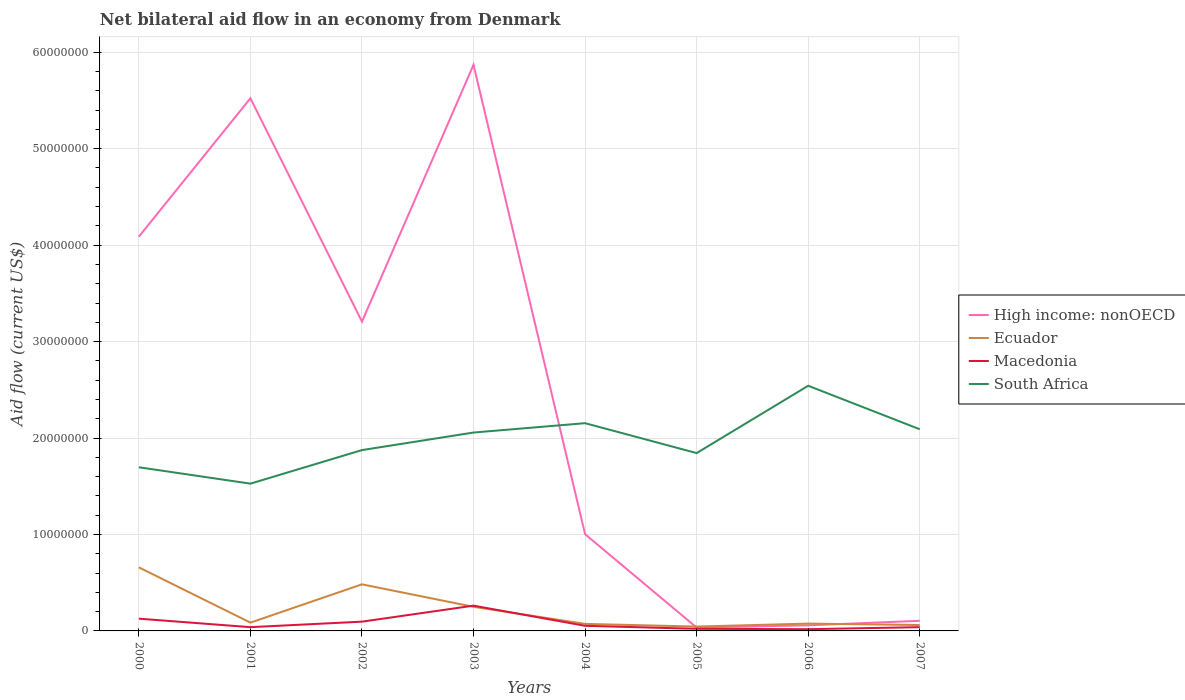How many different coloured lines are there?
Make the answer very short. 4. What is the total net bilateral aid flow in High income: nonOECD in the graph?
Your answer should be compact. -2.66e+07. What is the difference between the highest and the second highest net bilateral aid flow in High income: nonOECD?
Make the answer very short. 5.84e+07. What is the difference between the highest and the lowest net bilateral aid flow in High income: nonOECD?
Make the answer very short. 4. Is the net bilateral aid flow in Ecuador strictly greater than the net bilateral aid flow in Macedonia over the years?
Keep it short and to the point. No. Are the values on the major ticks of Y-axis written in scientific E-notation?
Offer a terse response. No. Does the graph contain grids?
Give a very brief answer. Yes. Where does the legend appear in the graph?
Offer a very short reply. Center right. What is the title of the graph?
Ensure brevity in your answer.  Net bilateral aid flow in an economy from Denmark. What is the label or title of the X-axis?
Provide a short and direct response. Years. What is the label or title of the Y-axis?
Keep it short and to the point. Aid flow (current US$). What is the Aid flow (current US$) of High income: nonOECD in 2000?
Make the answer very short. 4.09e+07. What is the Aid flow (current US$) in Ecuador in 2000?
Keep it short and to the point. 6.59e+06. What is the Aid flow (current US$) of Macedonia in 2000?
Offer a very short reply. 1.27e+06. What is the Aid flow (current US$) in South Africa in 2000?
Your answer should be very brief. 1.70e+07. What is the Aid flow (current US$) in High income: nonOECD in 2001?
Offer a terse response. 5.52e+07. What is the Aid flow (current US$) in Ecuador in 2001?
Offer a very short reply. 8.60e+05. What is the Aid flow (current US$) of South Africa in 2001?
Keep it short and to the point. 1.53e+07. What is the Aid flow (current US$) of High income: nonOECD in 2002?
Offer a terse response. 3.21e+07. What is the Aid flow (current US$) of Ecuador in 2002?
Your answer should be very brief. 4.83e+06. What is the Aid flow (current US$) in Macedonia in 2002?
Provide a short and direct response. 9.60e+05. What is the Aid flow (current US$) of South Africa in 2002?
Offer a very short reply. 1.88e+07. What is the Aid flow (current US$) in High income: nonOECD in 2003?
Offer a very short reply. 5.87e+07. What is the Aid flow (current US$) in Ecuador in 2003?
Offer a very short reply. 2.50e+06. What is the Aid flow (current US$) of Macedonia in 2003?
Offer a terse response. 2.62e+06. What is the Aid flow (current US$) in South Africa in 2003?
Ensure brevity in your answer.  2.06e+07. What is the Aid flow (current US$) in High income: nonOECD in 2004?
Ensure brevity in your answer.  1.00e+07. What is the Aid flow (current US$) in Ecuador in 2004?
Give a very brief answer. 7.30e+05. What is the Aid flow (current US$) in Macedonia in 2004?
Your answer should be compact. 5.30e+05. What is the Aid flow (current US$) in South Africa in 2004?
Offer a very short reply. 2.15e+07. What is the Aid flow (current US$) of High income: nonOECD in 2005?
Your answer should be very brief. 3.50e+05. What is the Aid flow (current US$) in Ecuador in 2005?
Your answer should be very brief. 4.50e+05. What is the Aid flow (current US$) in Macedonia in 2005?
Offer a very short reply. 2.20e+05. What is the Aid flow (current US$) in South Africa in 2005?
Your response must be concise. 1.84e+07. What is the Aid flow (current US$) of High income: nonOECD in 2006?
Make the answer very short. 5.80e+05. What is the Aid flow (current US$) of Ecuador in 2006?
Your answer should be compact. 7.60e+05. What is the Aid flow (current US$) of Macedonia in 2006?
Provide a short and direct response. 1.80e+05. What is the Aid flow (current US$) in South Africa in 2006?
Offer a terse response. 2.54e+07. What is the Aid flow (current US$) in High income: nonOECD in 2007?
Offer a very short reply. 1.05e+06. What is the Aid flow (current US$) of Ecuador in 2007?
Provide a short and direct response. 6.10e+05. What is the Aid flow (current US$) of Macedonia in 2007?
Keep it short and to the point. 3.90e+05. What is the Aid flow (current US$) in South Africa in 2007?
Ensure brevity in your answer.  2.09e+07. Across all years, what is the maximum Aid flow (current US$) of High income: nonOECD?
Your answer should be compact. 5.87e+07. Across all years, what is the maximum Aid flow (current US$) in Ecuador?
Offer a very short reply. 6.59e+06. Across all years, what is the maximum Aid flow (current US$) of Macedonia?
Your response must be concise. 2.62e+06. Across all years, what is the maximum Aid flow (current US$) in South Africa?
Your answer should be very brief. 2.54e+07. Across all years, what is the minimum Aid flow (current US$) of High income: nonOECD?
Make the answer very short. 3.50e+05. Across all years, what is the minimum Aid flow (current US$) in South Africa?
Offer a very short reply. 1.53e+07. What is the total Aid flow (current US$) of High income: nonOECD in the graph?
Ensure brevity in your answer.  1.99e+08. What is the total Aid flow (current US$) in Ecuador in the graph?
Keep it short and to the point. 1.73e+07. What is the total Aid flow (current US$) of Macedonia in the graph?
Provide a succinct answer. 6.56e+06. What is the total Aid flow (current US$) of South Africa in the graph?
Your answer should be very brief. 1.58e+08. What is the difference between the Aid flow (current US$) in High income: nonOECD in 2000 and that in 2001?
Give a very brief answer. -1.44e+07. What is the difference between the Aid flow (current US$) of Ecuador in 2000 and that in 2001?
Keep it short and to the point. 5.73e+06. What is the difference between the Aid flow (current US$) of Macedonia in 2000 and that in 2001?
Make the answer very short. 8.80e+05. What is the difference between the Aid flow (current US$) of South Africa in 2000 and that in 2001?
Make the answer very short. 1.70e+06. What is the difference between the Aid flow (current US$) in High income: nonOECD in 2000 and that in 2002?
Your answer should be very brief. 8.81e+06. What is the difference between the Aid flow (current US$) in Ecuador in 2000 and that in 2002?
Give a very brief answer. 1.76e+06. What is the difference between the Aid flow (current US$) in Macedonia in 2000 and that in 2002?
Your answer should be very brief. 3.10e+05. What is the difference between the Aid flow (current US$) in South Africa in 2000 and that in 2002?
Provide a short and direct response. -1.78e+06. What is the difference between the Aid flow (current US$) of High income: nonOECD in 2000 and that in 2003?
Your answer should be compact. -1.78e+07. What is the difference between the Aid flow (current US$) in Ecuador in 2000 and that in 2003?
Provide a short and direct response. 4.09e+06. What is the difference between the Aid flow (current US$) in Macedonia in 2000 and that in 2003?
Provide a short and direct response. -1.35e+06. What is the difference between the Aid flow (current US$) of South Africa in 2000 and that in 2003?
Provide a succinct answer. -3.60e+06. What is the difference between the Aid flow (current US$) of High income: nonOECD in 2000 and that in 2004?
Keep it short and to the point. 3.08e+07. What is the difference between the Aid flow (current US$) in Ecuador in 2000 and that in 2004?
Your response must be concise. 5.86e+06. What is the difference between the Aid flow (current US$) in Macedonia in 2000 and that in 2004?
Make the answer very short. 7.40e+05. What is the difference between the Aid flow (current US$) of South Africa in 2000 and that in 2004?
Offer a very short reply. -4.57e+06. What is the difference between the Aid flow (current US$) of High income: nonOECD in 2000 and that in 2005?
Offer a very short reply. 4.05e+07. What is the difference between the Aid flow (current US$) in Ecuador in 2000 and that in 2005?
Ensure brevity in your answer.  6.14e+06. What is the difference between the Aid flow (current US$) of Macedonia in 2000 and that in 2005?
Your answer should be very brief. 1.05e+06. What is the difference between the Aid flow (current US$) in South Africa in 2000 and that in 2005?
Offer a terse response. -1.47e+06. What is the difference between the Aid flow (current US$) of High income: nonOECD in 2000 and that in 2006?
Your answer should be very brief. 4.03e+07. What is the difference between the Aid flow (current US$) of Ecuador in 2000 and that in 2006?
Make the answer very short. 5.83e+06. What is the difference between the Aid flow (current US$) in Macedonia in 2000 and that in 2006?
Give a very brief answer. 1.09e+06. What is the difference between the Aid flow (current US$) in South Africa in 2000 and that in 2006?
Provide a short and direct response. -8.45e+06. What is the difference between the Aid flow (current US$) in High income: nonOECD in 2000 and that in 2007?
Your response must be concise. 3.98e+07. What is the difference between the Aid flow (current US$) of Ecuador in 2000 and that in 2007?
Make the answer very short. 5.98e+06. What is the difference between the Aid flow (current US$) in Macedonia in 2000 and that in 2007?
Offer a very short reply. 8.80e+05. What is the difference between the Aid flow (current US$) of South Africa in 2000 and that in 2007?
Your response must be concise. -3.94e+06. What is the difference between the Aid flow (current US$) of High income: nonOECD in 2001 and that in 2002?
Offer a terse response. 2.32e+07. What is the difference between the Aid flow (current US$) in Ecuador in 2001 and that in 2002?
Make the answer very short. -3.97e+06. What is the difference between the Aid flow (current US$) in Macedonia in 2001 and that in 2002?
Your answer should be compact. -5.70e+05. What is the difference between the Aid flow (current US$) of South Africa in 2001 and that in 2002?
Ensure brevity in your answer.  -3.48e+06. What is the difference between the Aid flow (current US$) of High income: nonOECD in 2001 and that in 2003?
Offer a terse response. -3.47e+06. What is the difference between the Aid flow (current US$) of Ecuador in 2001 and that in 2003?
Provide a short and direct response. -1.64e+06. What is the difference between the Aid flow (current US$) of Macedonia in 2001 and that in 2003?
Keep it short and to the point. -2.23e+06. What is the difference between the Aid flow (current US$) of South Africa in 2001 and that in 2003?
Give a very brief answer. -5.30e+06. What is the difference between the Aid flow (current US$) in High income: nonOECD in 2001 and that in 2004?
Offer a terse response. 4.52e+07. What is the difference between the Aid flow (current US$) in South Africa in 2001 and that in 2004?
Offer a very short reply. -6.27e+06. What is the difference between the Aid flow (current US$) in High income: nonOECD in 2001 and that in 2005?
Your answer should be very brief. 5.49e+07. What is the difference between the Aid flow (current US$) in Macedonia in 2001 and that in 2005?
Keep it short and to the point. 1.70e+05. What is the difference between the Aid flow (current US$) of South Africa in 2001 and that in 2005?
Offer a very short reply. -3.17e+06. What is the difference between the Aid flow (current US$) of High income: nonOECD in 2001 and that in 2006?
Your answer should be compact. 5.46e+07. What is the difference between the Aid flow (current US$) in Ecuador in 2001 and that in 2006?
Provide a succinct answer. 1.00e+05. What is the difference between the Aid flow (current US$) of Macedonia in 2001 and that in 2006?
Make the answer very short. 2.10e+05. What is the difference between the Aid flow (current US$) in South Africa in 2001 and that in 2006?
Provide a succinct answer. -1.02e+07. What is the difference between the Aid flow (current US$) of High income: nonOECD in 2001 and that in 2007?
Your response must be concise. 5.42e+07. What is the difference between the Aid flow (current US$) in Ecuador in 2001 and that in 2007?
Offer a very short reply. 2.50e+05. What is the difference between the Aid flow (current US$) of Macedonia in 2001 and that in 2007?
Ensure brevity in your answer.  0. What is the difference between the Aid flow (current US$) in South Africa in 2001 and that in 2007?
Your answer should be very brief. -5.64e+06. What is the difference between the Aid flow (current US$) in High income: nonOECD in 2002 and that in 2003?
Keep it short and to the point. -2.66e+07. What is the difference between the Aid flow (current US$) in Ecuador in 2002 and that in 2003?
Your answer should be compact. 2.33e+06. What is the difference between the Aid flow (current US$) in Macedonia in 2002 and that in 2003?
Your answer should be very brief. -1.66e+06. What is the difference between the Aid flow (current US$) in South Africa in 2002 and that in 2003?
Offer a terse response. -1.82e+06. What is the difference between the Aid flow (current US$) of High income: nonOECD in 2002 and that in 2004?
Provide a short and direct response. 2.20e+07. What is the difference between the Aid flow (current US$) in Ecuador in 2002 and that in 2004?
Ensure brevity in your answer.  4.10e+06. What is the difference between the Aid flow (current US$) of South Africa in 2002 and that in 2004?
Ensure brevity in your answer.  -2.79e+06. What is the difference between the Aid flow (current US$) in High income: nonOECD in 2002 and that in 2005?
Keep it short and to the point. 3.17e+07. What is the difference between the Aid flow (current US$) in Ecuador in 2002 and that in 2005?
Offer a terse response. 4.38e+06. What is the difference between the Aid flow (current US$) in Macedonia in 2002 and that in 2005?
Offer a terse response. 7.40e+05. What is the difference between the Aid flow (current US$) in South Africa in 2002 and that in 2005?
Your answer should be compact. 3.10e+05. What is the difference between the Aid flow (current US$) of High income: nonOECD in 2002 and that in 2006?
Give a very brief answer. 3.15e+07. What is the difference between the Aid flow (current US$) of Ecuador in 2002 and that in 2006?
Ensure brevity in your answer.  4.07e+06. What is the difference between the Aid flow (current US$) in Macedonia in 2002 and that in 2006?
Your answer should be compact. 7.80e+05. What is the difference between the Aid flow (current US$) of South Africa in 2002 and that in 2006?
Provide a short and direct response. -6.67e+06. What is the difference between the Aid flow (current US$) of High income: nonOECD in 2002 and that in 2007?
Keep it short and to the point. 3.10e+07. What is the difference between the Aid flow (current US$) of Ecuador in 2002 and that in 2007?
Offer a terse response. 4.22e+06. What is the difference between the Aid flow (current US$) in Macedonia in 2002 and that in 2007?
Offer a very short reply. 5.70e+05. What is the difference between the Aid flow (current US$) of South Africa in 2002 and that in 2007?
Keep it short and to the point. -2.16e+06. What is the difference between the Aid flow (current US$) of High income: nonOECD in 2003 and that in 2004?
Keep it short and to the point. 4.87e+07. What is the difference between the Aid flow (current US$) in Ecuador in 2003 and that in 2004?
Provide a succinct answer. 1.77e+06. What is the difference between the Aid flow (current US$) in Macedonia in 2003 and that in 2004?
Give a very brief answer. 2.09e+06. What is the difference between the Aid flow (current US$) in South Africa in 2003 and that in 2004?
Your answer should be compact. -9.70e+05. What is the difference between the Aid flow (current US$) of High income: nonOECD in 2003 and that in 2005?
Give a very brief answer. 5.84e+07. What is the difference between the Aid flow (current US$) in Ecuador in 2003 and that in 2005?
Ensure brevity in your answer.  2.05e+06. What is the difference between the Aid flow (current US$) in Macedonia in 2003 and that in 2005?
Offer a terse response. 2.40e+06. What is the difference between the Aid flow (current US$) of South Africa in 2003 and that in 2005?
Provide a succinct answer. 2.13e+06. What is the difference between the Aid flow (current US$) of High income: nonOECD in 2003 and that in 2006?
Make the answer very short. 5.81e+07. What is the difference between the Aid flow (current US$) of Ecuador in 2003 and that in 2006?
Offer a very short reply. 1.74e+06. What is the difference between the Aid flow (current US$) of Macedonia in 2003 and that in 2006?
Provide a short and direct response. 2.44e+06. What is the difference between the Aid flow (current US$) in South Africa in 2003 and that in 2006?
Offer a terse response. -4.85e+06. What is the difference between the Aid flow (current US$) in High income: nonOECD in 2003 and that in 2007?
Provide a short and direct response. 5.76e+07. What is the difference between the Aid flow (current US$) of Ecuador in 2003 and that in 2007?
Give a very brief answer. 1.89e+06. What is the difference between the Aid flow (current US$) in Macedonia in 2003 and that in 2007?
Give a very brief answer. 2.23e+06. What is the difference between the Aid flow (current US$) of High income: nonOECD in 2004 and that in 2005?
Your answer should be compact. 9.68e+06. What is the difference between the Aid flow (current US$) of South Africa in 2004 and that in 2005?
Your response must be concise. 3.10e+06. What is the difference between the Aid flow (current US$) in High income: nonOECD in 2004 and that in 2006?
Give a very brief answer. 9.45e+06. What is the difference between the Aid flow (current US$) of Ecuador in 2004 and that in 2006?
Provide a succinct answer. -3.00e+04. What is the difference between the Aid flow (current US$) in Macedonia in 2004 and that in 2006?
Your response must be concise. 3.50e+05. What is the difference between the Aid flow (current US$) in South Africa in 2004 and that in 2006?
Your answer should be compact. -3.88e+06. What is the difference between the Aid flow (current US$) in High income: nonOECD in 2004 and that in 2007?
Your answer should be very brief. 8.98e+06. What is the difference between the Aid flow (current US$) of Ecuador in 2004 and that in 2007?
Provide a short and direct response. 1.20e+05. What is the difference between the Aid flow (current US$) of Macedonia in 2004 and that in 2007?
Offer a terse response. 1.40e+05. What is the difference between the Aid flow (current US$) in South Africa in 2004 and that in 2007?
Your response must be concise. 6.30e+05. What is the difference between the Aid flow (current US$) in Ecuador in 2005 and that in 2006?
Ensure brevity in your answer.  -3.10e+05. What is the difference between the Aid flow (current US$) of Macedonia in 2005 and that in 2006?
Your answer should be very brief. 4.00e+04. What is the difference between the Aid flow (current US$) of South Africa in 2005 and that in 2006?
Keep it short and to the point. -6.98e+06. What is the difference between the Aid flow (current US$) in High income: nonOECD in 2005 and that in 2007?
Your response must be concise. -7.00e+05. What is the difference between the Aid flow (current US$) of Macedonia in 2005 and that in 2007?
Offer a terse response. -1.70e+05. What is the difference between the Aid flow (current US$) of South Africa in 2005 and that in 2007?
Provide a succinct answer. -2.47e+06. What is the difference between the Aid flow (current US$) in High income: nonOECD in 2006 and that in 2007?
Offer a very short reply. -4.70e+05. What is the difference between the Aid flow (current US$) in Ecuador in 2006 and that in 2007?
Keep it short and to the point. 1.50e+05. What is the difference between the Aid flow (current US$) of Macedonia in 2006 and that in 2007?
Offer a terse response. -2.10e+05. What is the difference between the Aid flow (current US$) of South Africa in 2006 and that in 2007?
Keep it short and to the point. 4.51e+06. What is the difference between the Aid flow (current US$) of High income: nonOECD in 2000 and the Aid flow (current US$) of Ecuador in 2001?
Provide a short and direct response. 4.00e+07. What is the difference between the Aid flow (current US$) of High income: nonOECD in 2000 and the Aid flow (current US$) of Macedonia in 2001?
Provide a succinct answer. 4.05e+07. What is the difference between the Aid flow (current US$) of High income: nonOECD in 2000 and the Aid flow (current US$) of South Africa in 2001?
Make the answer very short. 2.56e+07. What is the difference between the Aid flow (current US$) of Ecuador in 2000 and the Aid flow (current US$) of Macedonia in 2001?
Make the answer very short. 6.20e+06. What is the difference between the Aid flow (current US$) in Ecuador in 2000 and the Aid flow (current US$) in South Africa in 2001?
Your answer should be compact. -8.68e+06. What is the difference between the Aid flow (current US$) in Macedonia in 2000 and the Aid flow (current US$) in South Africa in 2001?
Your answer should be very brief. -1.40e+07. What is the difference between the Aid flow (current US$) in High income: nonOECD in 2000 and the Aid flow (current US$) in Ecuador in 2002?
Make the answer very short. 3.60e+07. What is the difference between the Aid flow (current US$) of High income: nonOECD in 2000 and the Aid flow (current US$) of Macedonia in 2002?
Offer a very short reply. 3.99e+07. What is the difference between the Aid flow (current US$) of High income: nonOECD in 2000 and the Aid flow (current US$) of South Africa in 2002?
Your answer should be very brief. 2.21e+07. What is the difference between the Aid flow (current US$) in Ecuador in 2000 and the Aid flow (current US$) in Macedonia in 2002?
Ensure brevity in your answer.  5.63e+06. What is the difference between the Aid flow (current US$) of Ecuador in 2000 and the Aid flow (current US$) of South Africa in 2002?
Provide a succinct answer. -1.22e+07. What is the difference between the Aid flow (current US$) in Macedonia in 2000 and the Aid flow (current US$) in South Africa in 2002?
Your answer should be compact. -1.75e+07. What is the difference between the Aid flow (current US$) of High income: nonOECD in 2000 and the Aid flow (current US$) of Ecuador in 2003?
Ensure brevity in your answer.  3.84e+07. What is the difference between the Aid flow (current US$) in High income: nonOECD in 2000 and the Aid flow (current US$) in Macedonia in 2003?
Give a very brief answer. 3.83e+07. What is the difference between the Aid flow (current US$) of High income: nonOECD in 2000 and the Aid flow (current US$) of South Africa in 2003?
Give a very brief answer. 2.03e+07. What is the difference between the Aid flow (current US$) of Ecuador in 2000 and the Aid flow (current US$) of Macedonia in 2003?
Your response must be concise. 3.97e+06. What is the difference between the Aid flow (current US$) of Ecuador in 2000 and the Aid flow (current US$) of South Africa in 2003?
Offer a very short reply. -1.40e+07. What is the difference between the Aid flow (current US$) of Macedonia in 2000 and the Aid flow (current US$) of South Africa in 2003?
Provide a succinct answer. -1.93e+07. What is the difference between the Aid flow (current US$) in High income: nonOECD in 2000 and the Aid flow (current US$) in Ecuador in 2004?
Make the answer very short. 4.02e+07. What is the difference between the Aid flow (current US$) in High income: nonOECD in 2000 and the Aid flow (current US$) in Macedonia in 2004?
Your response must be concise. 4.04e+07. What is the difference between the Aid flow (current US$) in High income: nonOECD in 2000 and the Aid flow (current US$) in South Africa in 2004?
Give a very brief answer. 1.93e+07. What is the difference between the Aid flow (current US$) of Ecuador in 2000 and the Aid flow (current US$) of Macedonia in 2004?
Your response must be concise. 6.06e+06. What is the difference between the Aid flow (current US$) in Ecuador in 2000 and the Aid flow (current US$) in South Africa in 2004?
Provide a short and direct response. -1.50e+07. What is the difference between the Aid flow (current US$) of Macedonia in 2000 and the Aid flow (current US$) of South Africa in 2004?
Offer a terse response. -2.03e+07. What is the difference between the Aid flow (current US$) in High income: nonOECD in 2000 and the Aid flow (current US$) in Ecuador in 2005?
Offer a terse response. 4.04e+07. What is the difference between the Aid flow (current US$) of High income: nonOECD in 2000 and the Aid flow (current US$) of Macedonia in 2005?
Offer a terse response. 4.07e+07. What is the difference between the Aid flow (current US$) in High income: nonOECD in 2000 and the Aid flow (current US$) in South Africa in 2005?
Ensure brevity in your answer.  2.24e+07. What is the difference between the Aid flow (current US$) in Ecuador in 2000 and the Aid flow (current US$) in Macedonia in 2005?
Provide a succinct answer. 6.37e+06. What is the difference between the Aid flow (current US$) of Ecuador in 2000 and the Aid flow (current US$) of South Africa in 2005?
Keep it short and to the point. -1.18e+07. What is the difference between the Aid flow (current US$) in Macedonia in 2000 and the Aid flow (current US$) in South Africa in 2005?
Your response must be concise. -1.72e+07. What is the difference between the Aid flow (current US$) in High income: nonOECD in 2000 and the Aid flow (current US$) in Ecuador in 2006?
Keep it short and to the point. 4.01e+07. What is the difference between the Aid flow (current US$) of High income: nonOECD in 2000 and the Aid flow (current US$) of Macedonia in 2006?
Provide a short and direct response. 4.07e+07. What is the difference between the Aid flow (current US$) in High income: nonOECD in 2000 and the Aid flow (current US$) in South Africa in 2006?
Provide a short and direct response. 1.55e+07. What is the difference between the Aid flow (current US$) of Ecuador in 2000 and the Aid flow (current US$) of Macedonia in 2006?
Your answer should be very brief. 6.41e+06. What is the difference between the Aid flow (current US$) in Ecuador in 2000 and the Aid flow (current US$) in South Africa in 2006?
Give a very brief answer. -1.88e+07. What is the difference between the Aid flow (current US$) in Macedonia in 2000 and the Aid flow (current US$) in South Africa in 2006?
Provide a succinct answer. -2.42e+07. What is the difference between the Aid flow (current US$) of High income: nonOECD in 2000 and the Aid flow (current US$) of Ecuador in 2007?
Ensure brevity in your answer.  4.03e+07. What is the difference between the Aid flow (current US$) in High income: nonOECD in 2000 and the Aid flow (current US$) in Macedonia in 2007?
Your response must be concise. 4.05e+07. What is the difference between the Aid flow (current US$) in High income: nonOECD in 2000 and the Aid flow (current US$) in South Africa in 2007?
Provide a succinct answer. 2.00e+07. What is the difference between the Aid flow (current US$) in Ecuador in 2000 and the Aid flow (current US$) in Macedonia in 2007?
Provide a succinct answer. 6.20e+06. What is the difference between the Aid flow (current US$) in Ecuador in 2000 and the Aid flow (current US$) in South Africa in 2007?
Offer a very short reply. -1.43e+07. What is the difference between the Aid flow (current US$) of Macedonia in 2000 and the Aid flow (current US$) of South Africa in 2007?
Your answer should be very brief. -1.96e+07. What is the difference between the Aid flow (current US$) in High income: nonOECD in 2001 and the Aid flow (current US$) in Ecuador in 2002?
Your answer should be compact. 5.04e+07. What is the difference between the Aid flow (current US$) in High income: nonOECD in 2001 and the Aid flow (current US$) in Macedonia in 2002?
Ensure brevity in your answer.  5.43e+07. What is the difference between the Aid flow (current US$) of High income: nonOECD in 2001 and the Aid flow (current US$) of South Africa in 2002?
Keep it short and to the point. 3.65e+07. What is the difference between the Aid flow (current US$) of Ecuador in 2001 and the Aid flow (current US$) of Macedonia in 2002?
Offer a very short reply. -1.00e+05. What is the difference between the Aid flow (current US$) in Ecuador in 2001 and the Aid flow (current US$) in South Africa in 2002?
Give a very brief answer. -1.79e+07. What is the difference between the Aid flow (current US$) in Macedonia in 2001 and the Aid flow (current US$) in South Africa in 2002?
Give a very brief answer. -1.84e+07. What is the difference between the Aid flow (current US$) of High income: nonOECD in 2001 and the Aid flow (current US$) of Ecuador in 2003?
Your answer should be very brief. 5.27e+07. What is the difference between the Aid flow (current US$) of High income: nonOECD in 2001 and the Aid flow (current US$) of Macedonia in 2003?
Provide a short and direct response. 5.26e+07. What is the difference between the Aid flow (current US$) in High income: nonOECD in 2001 and the Aid flow (current US$) in South Africa in 2003?
Give a very brief answer. 3.47e+07. What is the difference between the Aid flow (current US$) of Ecuador in 2001 and the Aid flow (current US$) of Macedonia in 2003?
Offer a very short reply. -1.76e+06. What is the difference between the Aid flow (current US$) in Ecuador in 2001 and the Aid flow (current US$) in South Africa in 2003?
Your response must be concise. -1.97e+07. What is the difference between the Aid flow (current US$) of Macedonia in 2001 and the Aid flow (current US$) of South Africa in 2003?
Your answer should be very brief. -2.02e+07. What is the difference between the Aid flow (current US$) in High income: nonOECD in 2001 and the Aid flow (current US$) in Ecuador in 2004?
Your answer should be very brief. 5.45e+07. What is the difference between the Aid flow (current US$) in High income: nonOECD in 2001 and the Aid flow (current US$) in Macedonia in 2004?
Your answer should be very brief. 5.47e+07. What is the difference between the Aid flow (current US$) of High income: nonOECD in 2001 and the Aid flow (current US$) of South Africa in 2004?
Offer a very short reply. 3.37e+07. What is the difference between the Aid flow (current US$) of Ecuador in 2001 and the Aid flow (current US$) of Macedonia in 2004?
Your answer should be very brief. 3.30e+05. What is the difference between the Aid flow (current US$) in Ecuador in 2001 and the Aid flow (current US$) in South Africa in 2004?
Provide a succinct answer. -2.07e+07. What is the difference between the Aid flow (current US$) in Macedonia in 2001 and the Aid flow (current US$) in South Africa in 2004?
Your answer should be very brief. -2.12e+07. What is the difference between the Aid flow (current US$) in High income: nonOECD in 2001 and the Aid flow (current US$) in Ecuador in 2005?
Your answer should be compact. 5.48e+07. What is the difference between the Aid flow (current US$) of High income: nonOECD in 2001 and the Aid flow (current US$) of Macedonia in 2005?
Ensure brevity in your answer.  5.50e+07. What is the difference between the Aid flow (current US$) of High income: nonOECD in 2001 and the Aid flow (current US$) of South Africa in 2005?
Give a very brief answer. 3.68e+07. What is the difference between the Aid flow (current US$) of Ecuador in 2001 and the Aid flow (current US$) of Macedonia in 2005?
Your answer should be compact. 6.40e+05. What is the difference between the Aid flow (current US$) of Ecuador in 2001 and the Aid flow (current US$) of South Africa in 2005?
Keep it short and to the point. -1.76e+07. What is the difference between the Aid flow (current US$) in Macedonia in 2001 and the Aid flow (current US$) in South Africa in 2005?
Keep it short and to the point. -1.80e+07. What is the difference between the Aid flow (current US$) of High income: nonOECD in 2001 and the Aid flow (current US$) of Ecuador in 2006?
Your answer should be very brief. 5.45e+07. What is the difference between the Aid flow (current US$) in High income: nonOECD in 2001 and the Aid flow (current US$) in Macedonia in 2006?
Offer a terse response. 5.50e+07. What is the difference between the Aid flow (current US$) of High income: nonOECD in 2001 and the Aid flow (current US$) of South Africa in 2006?
Your response must be concise. 2.98e+07. What is the difference between the Aid flow (current US$) of Ecuador in 2001 and the Aid flow (current US$) of Macedonia in 2006?
Offer a terse response. 6.80e+05. What is the difference between the Aid flow (current US$) in Ecuador in 2001 and the Aid flow (current US$) in South Africa in 2006?
Provide a succinct answer. -2.46e+07. What is the difference between the Aid flow (current US$) in Macedonia in 2001 and the Aid flow (current US$) in South Africa in 2006?
Provide a succinct answer. -2.50e+07. What is the difference between the Aid flow (current US$) of High income: nonOECD in 2001 and the Aid flow (current US$) of Ecuador in 2007?
Make the answer very short. 5.46e+07. What is the difference between the Aid flow (current US$) in High income: nonOECD in 2001 and the Aid flow (current US$) in Macedonia in 2007?
Provide a succinct answer. 5.48e+07. What is the difference between the Aid flow (current US$) in High income: nonOECD in 2001 and the Aid flow (current US$) in South Africa in 2007?
Your response must be concise. 3.43e+07. What is the difference between the Aid flow (current US$) in Ecuador in 2001 and the Aid flow (current US$) in South Africa in 2007?
Your answer should be compact. -2.00e+07. What is the difference between the Aid flow (current US$) in Macedonia in 2001 and the Aid flow (current US$) in South Africa in 2007?
Make the answer very short. -2.05e+07. What is the difference between the Aid flow (current US$) of High income: nonOECD in 2002 and the Aid flow (current US$) of Ecuador in 2003?
Your answer should be very brief. 2.96e+07. What is the difference between the Aid flow (current US$) of High income: nonOECD in 2002 and the Aid flow (current US$) of Macedonia in 2003?
Give a very brief answer. 2.94e+07. What is the difference between the Aid flow (current US$) in High income: nonOECD in 2002 and the Aid flow (current US$) in South Africa in 2003?
Give a very brief answer. 1.15e+07. What is the difference between the Aid flow (current US$) of Ecuador in 2002 and the Aid flow (current US$) of Macedonia in 2003?
Your answer should be very brief. 2.21e+06. What is the difference between the Aid flow (current US$) in Ecuador in 2002 and the Aid flow (current US$) in South Africa in 2003?
Offer a very short reply. -1.57e+07. What is the difference between the Aid flow (current US$) in Macedonia in 2002 and the Aid flow (current US$) in South Africa in 2003?
Your answer should be compact. -1.96e+07. What is the difference between the Aid flow (current US$) of High income: nonOECD in 2002 and the Aid flow (current US$) of Ecuador in 2004?
Make the answer very short. 3.13e+07. What is the difference between the Aid flow (current US$) in High income: nonOECD in 2002 and the Aid flow (current US$) in Macedonia in 2004?
Give a very brief answer. 3.15e+07. What is the difference between the Aid flow (current US$) of High income: nonOECD in 2002 and the Aid flow (current US$) of South Africa in 2004?
Provide a succinct answer. 1.05e+07. What is the difference between the Aid flow (current US$) in Ecuador in 2002 and the Aid flow (current US$) in Macedonia in 2004?
Your response must be concise. 4.30e+06. What is the difference between the Aid flow (current US$) in Ecuador in 2002 and the Aid flow (current US$) in South Africa in 2004?
Keep it short and to the point. -1.67e+07. What is the difference between the Aid flow (current US$) of Macedonia in 2002 and the Aid flow (current US$) of South Africa in 2004?
Offer a terse response. -2.06e+07. What is the difference between the Aid flow (current US$) in High income: nonOECD in 2002 and the Aid flow (current US$) in Ecuador in 2005?
Provide a succinct answer. 3.16e+07. What is the difference between the Aid flow (current US$) in High income: nonOECD in 2002 and the Aid flow (current US$) in Macedonia in 2005?
Provide a short and direct response. 3.18e+07. What is the difference between the Aid flow (current US$) of High income: nonOECD in 2002 and the Aid flow (current US$) of South Africa in 2005?
Offer a terse response. 1.36e+07. What is the difference between the Aid flow (current US$) of Ecuador in 2002 and the Aid flow (current US$) of Macedonia in 2005?
Make the answer very short. 4.61e+06. What is the difference between the Aid flow (current US$) in Ecuador in 2002 and the Aid flow (current US$) in South Africa in 2005?
Offer a very short reply. -1.36e+07. What is the difference between the Aid flow (current US$) of Macedonia in 2002 and the Aid flow (current US$) of South Africa in 2005?
Make the answer very short. -1.75e+07. What is the difference between the Aid flow (current US$) in High income: nonOECD in 2002 and the Aid flow (current US$) in Ecuador in 2006?
Make the answer very short. 3.13e+07. What is the difference between the Aid flow (current US$) of High income: nonOECD in 2002 and the Aid flow (current US$) of Macedonia in 2006?
Your answer should be very brief. 3.19e+07. What is the difference between the Aid flow (current US$) of High income: nonOECD in 2002 and the Aid flow (current US$) of South Africa in 2006?
Provide a succinct answer. 6.65e+06. What is the difference between the Aid flow (current US$) in Ecuador in 2002 and the Aid flow (current US$) in Macedonia in 2006?
Ensure brevity in your answer.  4.65e+06. What is the difference between the Aid flow (current US$) in Ecuador in 2002 and the Aid flow (current US$) in South Africa in 2006?
Provide a short and direct response. -2.06e+07. What is the difference between the Aid flow (current US$) of Macedonia in 2002 and the Aid flow (current US$) of South Africa in 2006?
Ensure brevity in your answer.  -2.45e+07. What is the difference between the Aid flow (current US$) in High income: nonOECD in 2002 and the Aid flow (current US$) in Ecuador in 2007?
Give a very brief answer. 3.15e+07. What is the difference between the Aid flow (current US$) of High income: nonOECD in 2002 and the Aid flow (current US$) of Macedonia in 2007?
Give a very brief answer. 3.17e+07. What is the difference between the Aid flow (current US$) of High income: nonOECD in 2002 and the Aid flow (current US$) of South Africa in 2007?
Your answer should be very brief. 1.12e+07. What is the difference between the Aid flow (current US$) in Ecuador in 2002 and the Aid flow (current US$) in Macedonia in 2007?
Provide a short and direct response. 4.44e+06. What is the difference between the Aid flow (current US$) in Ecuador in 2002 and the Aid flow (current US$) in South Africa in 2007?
Your answer should be very brief. -1.61e+07. What is the difference between the Aid flow (current US$) in Macedonia in 2002 and the Aid flow (current US$) in South Africa in 2007?
Provide a succinct answer. -2.00e+07. What is the difference between the Aid flow (current US$) of High income: nonOECD in 2003 and the Aid flow (current US$) of Ecuador in 2004?
Provide a short and direct response. 5.80e+07. What is the difference between the Aid flow (current US$) of High income: nonOECD in 2003 and the Aid flow (current US$) of Macedonia in 2004?
Provide a succinct answer. 5.82e+07. What is the difference between the Aid flow (current US$) in High income: nonOECD in 2003 and the Aid flow (current US$) in South Africa in 2004?
Provide a short and direct response. 3.72e+07. What is the difference between the Aid flow (current US$) of Ecuador in 2003 and the Aid flow (current US$) of Macedonia in 2004?
Give a very brief answer. 1.97e+06. What is the difference between the Aid flow (current US$) of Ecuador in 2003 and the Aid flow (current US$) of South Africa in 2004?
Your answer should be compact. -1.90e+07. What is the difference between the Aid flow (current US$) in Macedonia in 2003 and the Aid flow (current US$) in South Africa in 2004?
Your response must be concise. -1.89e+07. What is the difference between the Aid flow (current US$) in High income: nonOECD in 2003 and the Aid flow (current US$) in Ecuador in 2005?
Ensure brevity in your answer.  5.82e+07. What is the difference between the Aid flow (current US$) of High income: nonOECD in 2003 and the Aid flow (current US$) of Macedonia in 2005?
Provide a short and direct response. 5.85e+07. What is the difference between the Aid flow (current US$) in High income: nonOECD in 2003 and the Aid flow (current US$) in South Africa in 2005?
Ensure brevity in your answer.  4.03e+07. What is the difference between the Aid flow (current US$) in Ecuador in 2003 and the Aid flow (current US$) in Macedonia in 2005?
Your answer should be very brief. 2.28e+06. What is the difference between the Aid flow (current US$) of Ecuador in 2003 and the Aid flow (current US$) of South Africa in 2005?
Ensure brevity in your answer.  -1.59e+07. What is the difference between the Aid flow (current US$) of Macedonia in 2003 and the Aid flow (current US$) of South Africa in 2005?
Make the answer very short. -1.58e+07. What is the difference between the Aid flow (current US$) in High income: nonOECD in 2003 and the Aid flow (current US$) in Ecuador in 2006?
Your answer should be compact. 5.79e+07. What is the difference between the Aid flow (current US$) of High income: nonOECD in 2003 and the Aid flow (current US$) of Macedonia in 2006?
Your response must be concise. 5.85e+07. What is the difference between the Aid flow (current US$) in High income: nonOECD in 2003 and the Aid flow (current US$) in South Africa in 2006?
Give a very brief answer. 3.33e+07. What is the difference between the Aid flow (current US$) in Ecuador in 2003 and the Aid flow (current US$) in Macedonia in 2006?
Offer a very short reply. 2.32e+06. What is the difference between the Aid flow (current US$) of Ecuador in 2003 and the Aid flow (current US$) of South Africa in 2006?
Offer a terse response. -2.29e+07. What is the difference between the Aid flow (current US$) of Macedonia in 2003 and the Aid flow (current US$) of South Africa in 2006?
Provide a succinct answer. -2.28e+07. What is the difference between the Aid flow (current US$) in High income: nonOECD in 2003 and the Aid flow (current US$) in Ecuador in 2007?
Keep it short and to the point. 5.81e+07. What is the difference between the Aid flow (current US$) in High income: nonOECD in 2003 and the Aid flow (current US$) in Macedonia in 2007?
Your answer should be very brief. 5.83e+07. What is the difference between the Aid flow (current US$) in High income: nonOECD in 2003 and the Aid flow (current US$) in South Africa in 2007?
Provide a short and direct response. 3.78e+07. What is the difference between the Aid flow (current US$) in Ecuador in 2003 and the Aid flow (current US$) in Macedonia in 2007?
Your answer should be very brief. 2.11e+06. What is the difference between the Aid flow (current US$) in Ecuador in 2003 and the Aid flow (current US$) in South Africa in 2007?
Your answer should be compact. -1.84e+07. What is the difference between the Aid flow (current US$) of Macedonia in 2003 and the Aid flow (current US$) of South Africa in 2007?
Provide a succinct answer. -1.83e+07. What is the difference between the Aid flow (current US$) in High income: nonOECD in 2004 and the Aid flow (current US$) in Ecuador in 2005?
Your answer should be compact. 9.58e+06. What is the difference between the Aid flow (current US$) of High income: nonOECD in 2004 and the Aid flow (current US$) of Macedonia in 2005?
Your answer should be compact. 9.81e+06. What is the difference between the Aid flow (current US$) of High income: nonOECD in 2004 and the Aid flow (current US$) of South Africa in 2005?
Offer a terse response. -8.41e+06. What is the difference between the Aid flow (current US$) in Ecuador in 2004 and the Aid flow (current US$) in Macedonia in 2005?
Make the answer very short. 5.10e+05. What is the difference between the Aid flow (current US$) in Ecuador in 2004 and the Aid flow (current US$) in South Africa in 2005?
Provide a succinct answer. -1.77e+07. What is the difference between the Aid flow (current US$) in Macedonia in 2004 and the Aid flow (current US$) in South Africa in 2005?
Offer a very short reply. -1.79e+07. What is the difference between the Aid flow (current US$) of High income: nonOECD in 2004 and the Aid flow (current US$) of Ecuador in 2006?
Provide a short and direct response. 9.27e+06. What is the difference between the Aid flow (current US$) of High income: nonOECD in 2004 and the Aid flow (current US$) of Macedonia in 2006?
Provide a succinct answer. 9.85e+06. What is the difference between the Aid flow (current US$) of High income: nonOECD in 2004 and the Aid flow (current US$) of South Africa in 2006?
Provide a succinct answer. -1.54e+07. What is the difference between the Aid flow (current US$) in Ecuador in 2004 and the Aid flow (current US$) in Macedonia in 2006?
Your answer should be compact. 5.50e+05. What is the difference between the Aid flow (current US$) in Ecuador in 2004 and the Aid flow (current US$) in South Africa in 2006?
Ensure brevity in your answer.  -2.47e+07. What is the difference between the Aid flow (current US$) of Macedonia in 2004 and the Aid flow (current US$) of South Africa in 2006?
Make the answer very short. -2.49e+07. What is the difference between the Aid flow (current US$) in High income: nonOECD in 2004 and the Aid flow (current US$) in Ecuador in 2007?
Your answer should be very brief. 9.42e+06. What is the difference between the Aid flow (current US$) in High income: nonOECD in 2004 and the Aid flow (current US$) in Macedonia in 2007?
Give a very brief answer. 9.64e+06. What is the difference between the Aid flow (current US$) of High income: nonOECD in 2004 and the Aid flow (current US$) of South Africa in 2007?
Keep it short and to the point. -1.09e+07. What is the difference between the Aid flow (current US$) in Ecuador in 2004 and the Aid flow (current US$) in South Africa in 2007?
Give a very brief answer. -2.02e+07. What is the difference between the Aid flow (current US$) in Macedonia in 2004 and the Aid flow (current US$) in South Africa in 2007?
Offer a terse response. -2.04e+07. What is the difference between the Aid flow (current US$) of High income: nonOECD in 2005 and the Aid flow (current US$) of Ecuador in 2006?
Make the answer very short. -4.10e+05. What is the difference between the Aid flow (current US$) of High income: nonOECD in 2005 and the Aid flow (current US$) of South Africa in 2006?
Your response must be concise. -2.51e+07. What is the difference between the Aid flow (current US$) of Ecuador in 2005 and the Aid flow (current US$) of Macedonia in 2006?
Offer a very short reply. 2.70e+05. What is the difference between the Aid flow (current US$) in Ecuador in 2005 and the Aid flow (current US$) in South Africa in 2006?
Your answer should be compact. -2.50e+07. What is the difference between the Aid flow (current US$) of Macedonia in 2005 and the Aid flow (current US$) of South Africa in 2006?
Your answer should be compact. -2.52e+07. What is the difference between the Aid flow (current US$) in High income: nonOECD in 2005 and the Aid flow (current US$) in Macedonia in 2007?
Make the answer very short. -4.00e+04. What is the difference between the Aid flow (current US$) of High income: nonOECD in 2005 and the Aid flow (current US$) of South Africa in 2007?
Make the answer very short. -2.06e+07. What is the difference between the Aid flow (current US$) in Ecuador in 2005 and the Aid flow (current US$) in South Africa in 2007?
Provide a succinct answer. -2.05e+07. What is the difference between the Aid flow (current US$) of Macedonia in 2005 and the Aid flow (current US$) of South Africa in 2007?
Keep it short and to the point. -2.07e+07. What is the difference between the Aid flow (current US$) in High income: nonOECD in 2006 and the Aid flow (current US$) in Ecuador in 2007?
Offer a very short reply. -3.00e+04. What is the difference between the Aid flow (current US$) of High income: nonOECD in 2006 and the Aid flow (current US$) of Macedonia in 2007?
Give a very brief answer. 1.90e+05. What is the difference between the Aid flow (current US$) of High income: nonOECD in 2006 and the Aid flow (current US$) of South Africa in 2007?
Offer a very short reply. -2.03e+07. What is the difference between the Aid flow (current US$) in Ecuador in 2006 and the Aid flow (current US$) in Macedonia in 2007?
Keep it short and to the point. 3.70e+05. What is the difference between the Aid flow (current US$) of Ecuador in 2006 and the Aid flow (current US$) of South Africa in 2007?
Your answer should be very brief. -2.02e+07. What is the difference between the Aid flow (current US$) of Macedonia in 2006 and the Aid flow (current US$) of South Africa in 2007?
Make the answer very short. -2.07e+07. What is the average Aid flow (current US$) in High income: nonOECD per year?
Make the answer very short. 2.49e+07. What is the average Aid flow (current US$) of Ecuador per year?
Your response must be concise. 2.17e+06. What is the average Aid flow (current US$) of Macedonia per year?
Your response must be concise. 8.20e+05. What is the average Aid flow (current US$) of South Africa per year?
Offer a very short reply. 1.97e+07. In the year 2000, what is the difference between the Aid flow (current US$) of High income: nonOECD and Aid flow (current US$) of Ecuador?
Ensure brevity in your answer.  3.43e+07. In the year 2000, what is the difference between the Aid flow (current US$) of High income: nonOECD and Aid flow (current US$) of Macedonia?
Provide a succinct answer. 3.96e+07. In the year 2000, what is the difference between the Aid flow (current US$) of High income: nonOECD and Aid flow (current US$) of South Africa?
Your answer should be compact. 2.39e+07. In the year 2000, what is the difference between the Aid flow (current US$) in Ecuador and Aid flow (current US$) in Macedonia?
Provide a short and direct response. 5.32e+06. In the year 2000, what is the difference between the Aid flow (current US$) of Ecuador and Aid flow (current US$) of South Africa?
Provide a succinct answer. -1.04e+07. In the year 2000, what is the difference between the Aid flow (current US$) in Macedonia and Aid flow (current US$) in South Africa?
Keep it short and to the point. -1.57e+07. In the year 2001, what is the difference between the Aid flow (current US$) in High income: nonOECD and Aid flow (current US$) in Ecuador?
Your response must be concise. 5.44e+07. In the year 2001, what is the difference between the Aid flow (current US$) of High income: nonOECD and Aid flow (current US$) of Macedonia?
Make the answer very short. 5.48e+07. In the year 2001, what is the difference between the Aid flow (current US$) in High income: nonOECD and Aid flow (current US$) in South Africa?
Provide a succinct answer. 4.00e+07. In the year 2001, what is the difference between the Aid flow (current US$) of Ecuador and Aid flow (current US$) of Macedonia?
Make the answer very short. 4.70e+05. In the year 2001, what is the difference between the Aid flow (current US$) of Ecuador and Aid flow (current US$) of South Africa?
Your response must be concise. -1.44e+07. In the year 2001, what is the difference between the Aid flow (current US$) of Macedonia and Aid flow (current US$) of South Africa?
Provide a short and direct response. -1.49e+07. In the year 2002, what is the difference between the Aid flow (current US$) of High income: nonOECD and Aid flow (current US$) of Ecuador?
Keep it short and to the point. 2.72e+07. In the year 2002, what is the difference between the Aid flow (current US$) of High income: nonOECD and Aid flow (current US$) of Macedonia?
Offer a very short reply. 3.11e+07. In the year 2002, what is the difference between the Aid flow (current US$) of High income: nonOECD and Aid flow (current US$) of South Africa?
Offer a very short reply. 1.33e+07. In the year 2002, what is the difference between the Aid flow (current US$) of Ecuador and Aid flow (current US$) of Macedonia?
Keep it short and to the point. 3.87e+06. In the year 2002, what is the difference between the Aid flow (current US$) in Ecuador and Aid flow (current US$) in South Africa?
Your answer should be compact. -1.39e+07. In the year 2002, what is the difference between the Aid flow (current US$) of Macedonia and Aid flow (current US$) of South Africa?
Give a very brief answer. -1.78e+07. In the year 2003, what is the difference between the Aid flow (current US$) of High income: nonOECD and Aid flow (current US$) of Ecuador?
Offer a very short reply. 5.62e+07. In the year 2003, what is the difference between the Aid flow (current US$) of High income: nonOECD and Aid flow (current US$) of Macedonia?
Ensure brevity in your answer.  5.61e+07. In the year 2003, what is the difference between the Aid flow (current US$) of High income: nonOECD and Aid flow (current US$) of South Africa?
Your response must be concise. 3.81e+07. In the year 2003, what is the difference between the Aid flow (current US$) of Ecuador and Aid flow (current US$) of South Africa?
Make the answer very short. -1.81e+07. In the year 2003, what is the difference between the Aid flow (current US$) in Macedonia and Aid flow (current US$) in South Africa?
Your answer should be compact. -1.80e+07. In the year 2004, what is the difference between the Aid flow (current US$) of High income: nonOECD and Aid flow (current US$) of Ecuador?
Your answer should be very brief. 9.30e+06. In the year 2004, what is the difference between the Aid flow (current US$) of High income: nonOECD and Aid flow (current US$) of Macedonia?
Offer a terse response. 9.50e+06. In the year 2004, what is the difference between the Aid flow (current US$) in High income: nonOECD and Aid flow (current US$) in South Africa?
Your answer should be compact. -1.15e+07. In the year 2004, what is the difference between the Aid flow (current US$) in Ecuador and Aid flow (current US$) in South Africa?
Offer a very short reply. -2.08e+07. In the year 2004, what is the difference between the Aid flow (current US$) of Macedonia and Aid flow (current US$) of South Africa?
Offer a very short reply. -2.10e+07. In the year 2005, what is the difference between the Aid flow (current US$) of High income: nonOECD and Aid flow (current US$) of Macedonia?
Your answer should be very brief. 1.30e+05. In the year 2005, what is the difference between the Aid flow (current US$) of High income: nonOECD and Aid flow (current US$) of South Africa?
Ensure brevity in your answer.  -1.81e+07. In the year 2005, what is the difference between the Aid flow (current US$) of Ecuador and Aid flow (current US$) of South Africa?
Provide a short and direct response. -1.80e+07. In the year 2005, what is the difference between the Aid flow (current US$) of Macedonia and Aid flow (current US$) of South Africa?
Ensure brevity in your answer.  -1.82e+07. In the year 2006, what is the difference between the Aid flow (current US$) of High income: nonOECD and Aid flow (current US$) of South Africa?
Ensure brevity in your answer.  -2.48e+07. In the year 2006, what is the difference between the Aid flow (current US$) in Ecuador and Aid flow (current US$) in Macedonia?
Keep it short and to the point. 5.80e+05. In the year 2006, what is the difference between the Aid flow (current US$) in Ecuador and Aid flow (current US$) in South Africa?
Give a very brief answer. -2.47e+07. In the year 2006, what is the difference between the Aid flow (current US$) of Macedonia and Aid flow (current US$) of South Africa?
Keep it short and to the point. -2.52e+07. In the year 2007, what is the difference between the Aid flow (current US$) of High income: nonOECD and Aid flow (current US$) of Ecuador?
Provide a short and direct response. 4.40e+05. In the year 2007, what is the difference between the Aid flow (current US$) in High income: nonOECD and Aid flow (current US$) in Macedonia?
Provide a short and direct response. 6.60e+05. In the year 2007, what is the difference between the Aid flow (current US$) of High income: nonOECD and Aid flow (current US$) of South Africa?
Your response must be concise. -1.99e+07. In the year 2007, what is the difference between the Aid flow (current US$) in Ecuador and Aid flow (current US$) in Macedonia?
Your answer should be compact. 2.20e+05. In the year 2007, what is the difference between the Aid flow (current US$) in Ecuador and Aid flow (current US$) in South Africa?
Give a very brief answer. -2.03e+07. In the year 2007, what is the difference between the Aid flow (current US$) of Macedonia and Aid flow (current US$) of South Africa?
Your answer should be compact. -2.05e+07. What is the ratio of the Aid flow (current US$) in High income: nonOECD in 2000 to that in 2001?
Offer a terse response. 0.74. What is the ratio of the Aid flow (current US$) of Ecuador in 2000 to that in 2001?
Provide a succinct answer. 7.66. What is the ratio of the Aid flow (current US$) of Macedonia in 2000 to that in 2001?
Your response must be concise. 3.26. What is the ratio of the Aid flow (current US$) of South Africa in 2000 to that in 2001?
Make the answer very short. 1.11. What is the ratio of the Aid flow (current US$) in High income: nonOECD in 2000 to that in 2002?
Your response must be concise. 1.27. What is the ratio of the Aid flow (current US$) in Ecuador in 2000 to that in 2002?
Make the answer very short. 1.36. What is the ratio of the Aid flow (current US$) of Macedonia in 2000 to that in 2002?
Your answer should be very brief. 1.32. What is the ratio of the Aid flow (current US$) in South Africa in 2000 to that in 2002?
Your answer should be compact. 0.91. What is the ratio of the Aid flow (current US$) in High income: nonOECD in 2000 to that in 2003?
Keep it short and to the point. 0.7. What is the ratio of the Aid flow (current US$) in Ecuador in 2000 to that in 2003?
Provide a succinct answer. 2.64. What is the ratio of the Aid flow (current US$) in Macedonia in 2000 to that in 2003?
Offer a terse response. 0.48. What is the ratio of the Aid flow (current US$) in South Africa in 2000 to that in 2003?
Provide a short and direct response. 0.82. What is the ratio of the Aid flow (current US$) in High income: nonOECD in 2000 to that in 2004?
Offer a very short reply. 4.08. What is the ratio of the Aid flow (current US$) in Ecuador in 2000 to that in 2004?
Offer a terse response. 9.03. What is the ratio of the Aid flow (current US$) of Macedonia in 2000 to that in 2004?
Your answer should be very brief. 2.4. What is the ratio of the Aid flow (current US$) in South Africa in 2000 to that in 2004?
Ensure brevity in your answer.  0.79. What is the ratio of the Aid flow (current US$) of High income: nonOECD in 2000 to that in 2005?
Offer a very short reply. 116.8. What is the ratio of the Aid flow (current US$) in Ecuador in 2000 to that in 2005?
Your answer should be compact. 14.64. What is the ratio of the Aid flow (current US$) of Macedonia in 2000 to that in 2005?
Make the answer very short. 5.77. What is the ratio of the Aid flow (current US$) in South Africa in 2000 to that in 2005?
Your response must be concise. 0.92. What is the ratio of the Aid flow (current US$) of High income: nonOECD in 2000 to that in 2006?
Ensure brevity in your answer.  70.48. What is the ratio of the Aid flow (current US$) in Ecuador in 2000 to that in 2006?
Your answer should be very brief. 8.67. What is the ratio of the Aid flow (current US$) in Macedonia in 2000 to that in 2006?
Give a very brief answer. 7.06. What is the ratio of the Aid flow (current US$) of South Africa in 2000 to that in 2006?
Make the answer very short. 0.67. What is the ratio of the Aid flow (current US$) of High income: nonOECD in 2000 to that in 2007?
Your response must be concise. 38.93. What is the ratio of the Aid flow (current US$) in Ecuador in 2000 to that in 2007?
Your answer should be very brief. 10.8. What is the ratio of the Aid flow (current US$) in Macedonia in 2000 to that in 2007?
Make the answer very short. 3.26. What is the ratio of the Aid flow (current US$) of South Africa in 2000 to that in 2007?
Make the answer very short. 0.81. What is the ratio of the Aid flow (current US$) in High income: nonOECD in 2001 to that in 2002?
Ensure brevity in your answer.  1.72. What is the ratio of the Aid flow (current US$) of Ecuador in 2001 to that in 2002?
Offer a very short reply. 0.18. What is the ratio of the Aid flow (current US$) of Macedonia in 2001 to that in 2002?
Your answer should be compact. 0.41. What is the ratio of the Aid flow (current US$) in South Africa in 2001 to that in 2002?
Keep it short and to the point. 0.81. What is the ratio of the Aid flow (current US$) of High income: nonOECD in 2001 to that in 2003?
Provide a short and direct response. 0.94. What is the ratio of the Aid flow (current US$) in Ecuador in 2001 to that in 2003?
Your response must be concise. 0.34. What is the ratio of the Aid flow (current US$) of Macedonia in 2001 to that in 2003?
Your response must be concise. 0.15. What is the ratio of the Aid flow (current US$) in South Africa in 2001 to that in 2003?
Keep it short and to the point. 0.74. What is the ratio of the Aid flow (current US$) of High income: nonOECD in 2001 to that in 2004?
Give a very brief answer. 5.51. What is the ratio of the Aid flow (current US$) in Ecuador in 2001 to that in 2004?
Offer a terse response. 1.18. What is the ratio of the Aid flow (current US$) in Macedonia in 2001 to that in 2004?
Ensure brevity in your answer.  0.74. What is the ratio of the Aid flow (current US$) in South Africa in 2001 to that in 2004?
Your response must be concise. 0.71. What is the ratio of the Aid flow (current US$) in High income: nonOECD in 2001 to that in 2005?
Offer a very short reply. 157.8. What is the ratio of the Aid flow (current US$) of Ecuador in 2001 to that in 2005?
Provide a succinct answer. 1.91. What is the ratio of the Aid flow (current US$) of Macedonia in 2001 to that in 2005?
Provide a succinct answer. 1.77. What is the ratio of the Aid flow (current US$) in South Africa in 2001 to that in 2005?
Make the answer very short. 0.83. What is the ratio of the Aid flow (current US$) in High income: nonOECD in 2001 to that in 2006?
Offer a very short reply. 95.22. What is the ratio of the Aid flow (current US$) in Ecuador in 2001 to that in 2006?
Offer a very short reply. 1.13. What is the ratio of the Aid flow (current US$) in Macedonia in 2001 to that in 2006?
Provide a succinct answer. 2.17. What is the ratio of the Aid flow (current US$) of South Africa in 2001 to that in 2006?
Your response must be concise. 0.6. What is the ratio of the Aid flow (current US$) of High income: nonOECD in 2001 to that in 2007?
Keep it short and to the point. 52.6. What is the ratio of the Aid flow (current US$) of Ecuador in 2001 to that in 2007?
Provide a succinct answer. 1.41. What is the ratio of the Aid flow (current US$) in Macedonia in 2001 to that in 2007?
Your answer should be very brief. 1. What is the ratio of the Aid flow (current US$) of South Africa in 2001 to that in 2007?
Your response must be concise. 0.73. What is the ratio of the Aid flow (current US$) of High income: nonOECD in 2002 to that in 2003?
Give a very brief answer. 0.55. What is the ratio of the Aid flow (current US$) in Ecuador in 2002 to that in 2003?
Make the answer very short. 1.93. What is the ratio of the Aid flow (current US$) of Macedonia in 2002 to that in 2003?
Offer a very short reply. 0.37. What is the ratio of the Aid flow (current US$) in South Africa in 2002 to that in 2003?
Ensure brevity in your answer.  0.91. What is the ratio of the Aid flow (current US$) in High income: nonOECD in 2002 to that in 2004?
Your response must be concise. 3.2. What is the ratio of the Aid flow (current US$) of Ecuador in 2002 to that in 2004?
Provide a succinct answer. 6.62. What is the ratio of the Aid flow (current US$) of Macedonia in 2002 to that in 2004?
Offer a very short reply. 1.81. What is the ratio of the Aid flow (current US$) in South Africa in 2002 to that in 2004?
Offer a terse response. 0.87. What is the ratio of the Aid flow (current US$) of High income: nonOECD in 2002 to that in 2005?
Provide a succinct answer. 91.63. What is the ratio of the Aid flow (current US$) of Ecuador in 2002 to that in 2005?
Give a very brief answer. 10.73. What is the ratio of the Aid flow (current US$) of Macedonia in 2002 to that in 2005?
Make the answer very short. 4.36. What is the ratio of the Aid flow (current US$) of South Africa in 2002 to that in 2005?
Give a very brief answer. 1.02. What is the ratio of the Aid flow (current US$) in High income: nonOECD in 2002 to that in 2006?
Your answer should be very brief. 55.29. What is the ratio of the Aid flow (current US$) of Ecuador in 2002 to that in 2006?
Ensure brevity in your answer.  6.36. What is the ratio of the Aid flow (current US$) in Macedonia in 2002 to that in 2006?
Provide a short and direct response. 5.33. What is the ratio of the Aid flow (current US$) in South Africa in 2002 to that in 2006?
Give a very brief answer. 0.74. What is the ratio of the Aid flow (current US$) in High income: nonOECD in 2002 to that in 2007?
Ensure brevity in your answer.  30.54. What is the ratio of the Aid flow (current US$) of Ecuador in 2002 to that in 2007?
Ensure brevity in your answer.  7.92. What is the ratio of the Aid flow (current US$) in Macedonia in 2002 to that in 2007?
Give a very brief answer. 2.46. What is the ratio of the Aid flow (current US$) of South Africa in 2002 to that in 2007?
Provide a succinct answer. 0.9. What is the ratio of the Aid flow (current US$) in High income: nonOECD in 2003 to that in 2004?
Make the answer very short. 5.85. What is the ratio of the Aid flow (current US$) in Ecuador in 2003 to that in 2004?
Make the answer very short. 3.42. What is the ratio of the Aid flow (current US$) of Macedonia in 2003 to that in 2004?
Offer a terse response. 4.94. What is the ratio of the Aid flow (current US$) of South Africa in 2003 to that in 2004?
Keep it short and to the point. 0.95. What is the ratio of the Aid flow (current US$) in High income: nonOECD in 2003 to that in 2005?
Ensure brevity in your answer.  167.71. What is the ratio of the Aid flow (current US$) in Ecuador in 2003 to that in 2005?
Give a very brief answer. 5.56. What is the ratio of the Aid flow (current US$) of Macedonia in 2003 to that in 2005?
Ensure brevity in your answer.  11.91. What is the ratio of the Aid flow (current US$) of South Africa in 2003 to that in 2005?
Your response must be concise. 1.12. What is the ratio of the Aid flow (current US$) in High income: nonOECD in 2003 to that in 2006?
Your answer should be compact. 101.21. What is the ratio of the Aid flow (current US$) of Ecuador in 2003 to that in 2006?
Make the answer very short. 3.29. What is the ratio of the Aid flow (current US$) in Macedonia in 2003 to that in 2006?
Provide a short and direct response. 14.56. What is the ratio of the Aid flow (current US$) of South Africa in 2003 to that in 2006?
Your answer should be compact. 0.81. What is the ratio of the Aid flow (current US$) of High income: nonOECD in 2003 to that in 2007?
Your response must be concise. 55.9. What is the ratio of the Aid flow (current US$) in Ecuador in 2003 to that in 2007?
Ensure brevity in your answer.  4.1. What is the ratio of the Aid flow (current US$) of Macedonia in 2003 to that in 2007?
Your answer should be very brief. 6.72. What is the ratio of the Aid flow (current US$) of South Africa in 2003 to that in 2007?
Provide a short and direct response. 0.98. What is the ratio of the Aid flow (current US$) of High income: nonOECD in 2004 to that in 2005?
Keep it short and to the point. 28.66. What is the ratio of the Aid flow (current US$) in Ecuador in 2004 to that in 2005?
Provide a succinct answer. 1.62. What is the ratio of the Aid flow (current US$) of Macedonia in 2004 to that in 2005?
Give a very brief answer. 2.41. What is the ratio of the Aid flow (current US$) in South Africa in 2004 to that in 2005?
Give a very brief answer. 1.17. What is the ratio of the Aid flow (current US$) in High income: nonOECD in 2004 to that in 2006?
Provide a short and direct response. 17.29. What is the ratio of the Aid flow (current US$) in Ecuador in 2004 to that in 2006?
Offer a terse response. 0.96. What is the ratio of the Aid flow (current US$) of Macedonia in 2004 to that in 2006?
Provide a succinct answer. 2.94. What is the ratio of the Aid flow (current US$) in South Africa in 2004 to that in 2006?
Offer a terse response. 0.85. What is the ratio of the Aid flow (current US$) in High income: nonOECD in 2004 to that in 2007?
Provide a succinct answer. 9.55. What is the ratio of the Aid flow (current US$) of Ecuador in 2004 to that in 2007?
Your answer should be very brief. 1.2. What is the ratio of the Aid flow (current US$) of Macedonia in 2004 to that in 2007?
Keep it short and to the point. 1.36. What is the ratio of the Aid flow (current US$) in South Africa in 2004 to that in 2007?
Your response must be concise. 1.03. What is the ratio of the Aid flow (current US$) of High income: nonOECD in 2005 to that in 2006?
Offer a terse response. 0.6. What is the ratio of the Aid flow (current US$) of Ecuador in 2005 to that in 2006?
Keep it short and to the point. 0.59. What is the ratio of the Aid flow (current US$) of Macedonia in 2005 to that in 2006?
Your response must be concise. 1.22. What is the ratio of the Aid flow (current US$) in South Africa in 2005 to that in 2006?
Offer a very short reply. 0.73. What is the ratio of the Aid flow (current US$) of Ecuador in 2005 to that in 2007?
Provide a short and direct response. 0.74. What is the ratio of the Aid flow (current US$) in Macedonia in 2005 to that in 2007?
Make the answer very short. 0.56. What is the ratio of the Aid flow (current US$) in South Africa in 2005 to that in 2007?
Provide a short and direct response. 0.88. What is the ratio of the Aid flow (current US$) in High income: nonOECD in 2006 to that in 2007?
Your answer should be compact. 0.55. What is the ratio of the Aid flow (current US$) of Ecuador in 2006 to that in 2007?
Keep it short and to the point. 1.25. What is the ratio of the Aid flow (current US$) in Macedonia in 2006 to that in 2007?
Offer a very short reply. 0.46. What is the ratio of the Aid flow (current US$) in South Africa in 2006 to that in 2007?
Ensure brevity in your answer.  1.22. What is the difference between the highest and the second highest Aid flow (current US$) in High income: nonOECD?
Offer a terse response. 3.47e+06. What is the difference between the highest and the second highest Aid flow (current US$) in Ecuador?
Provide a succinct answer. 1.76e+06. What is the difference between the highest and the second highest Aid flow (current US$) in Macedonia?
Ensure brevity in your answer.  1.35e+06. What is the difference between the highest and the second highest Aid flow (current US$) in South Africa?
Your answer should be compact. 3.88e+06. What is the difference between the highest and the lowest Aid flow (current US$) in High income: nonOECD?
Offer a terse response. 5.84e+07. What is the difference between the highest and the lowest Aid flow (current US$) in Ecuador?
Make the answer very short. 6.14e+06. What is the difference between the highest and the lowest Aid flow (current US$) of Macedonia?
Offer a terse response. 2.44e+06. What is the difference between the highest and the lowest Aid flow (current US$) in South Africa?
Your answer should be very brief. 1.02e+07. 